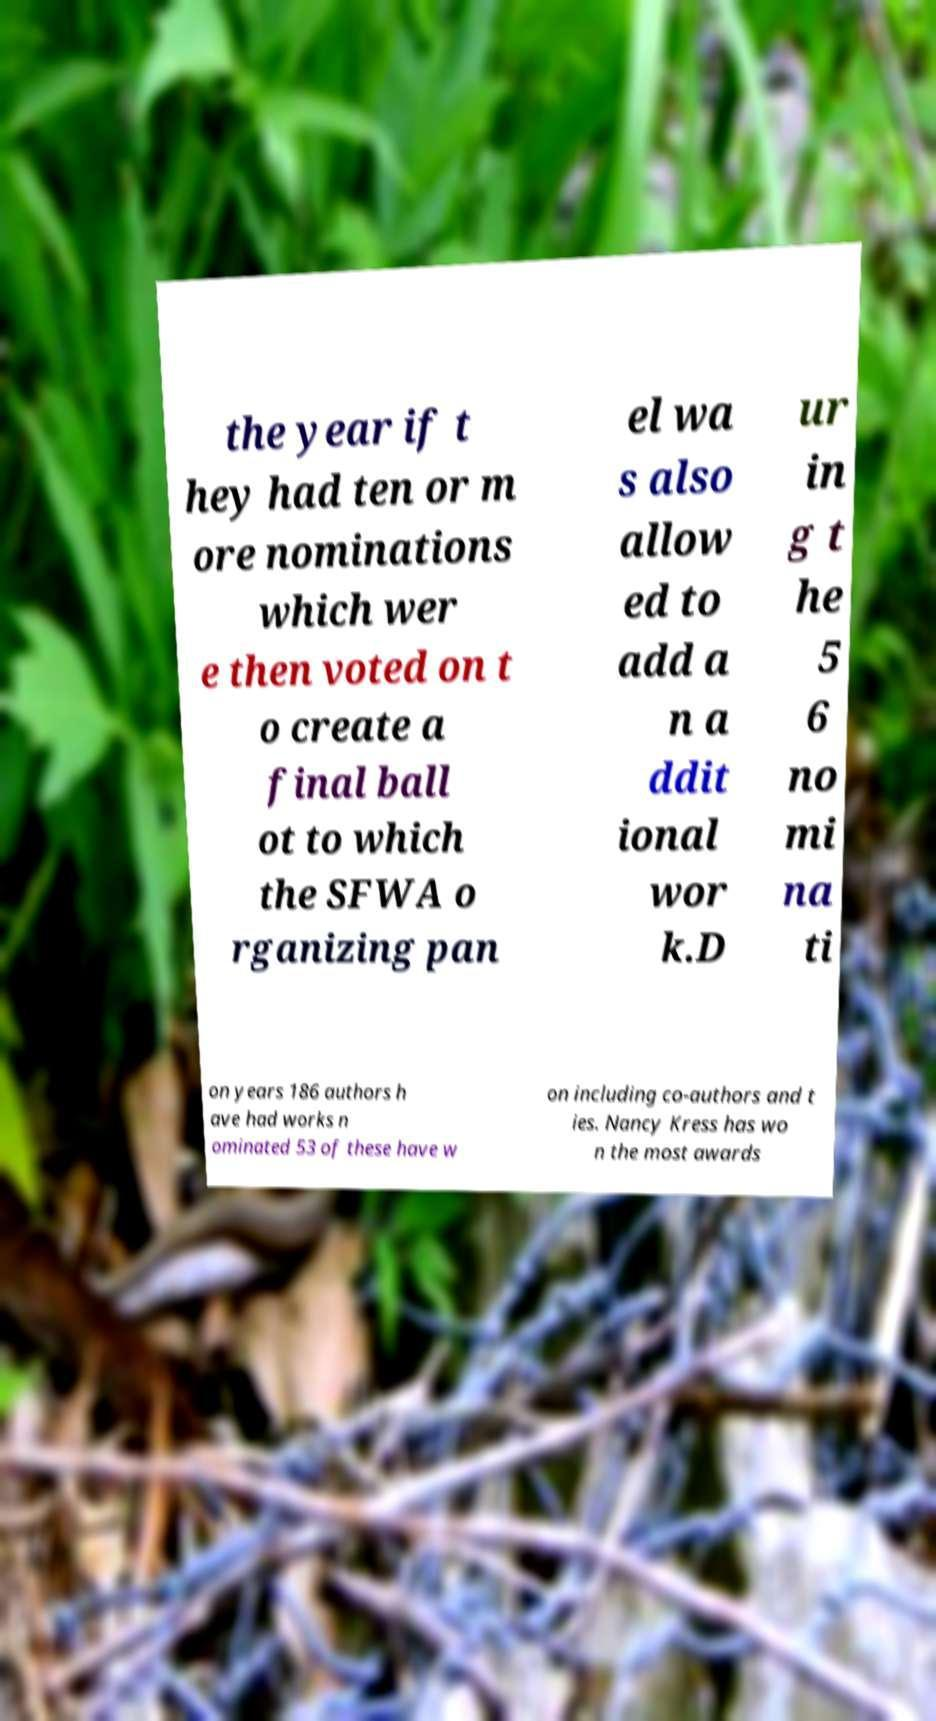For documentation purposes, I need the text within this image transcribed. Could you provide that? the year if t hey had ten or m ore nominations which wer e then voted on t o create a final ball ot to which the SFWA o rganizing pan el wa s also allow ed to add a n a ddit ional wor k.D ur in g t he 5 6 no mi na ti on years 186 authors h ave had works n ominated 53 of these have w on including co-authors and t ies. Nancy Kress has wo n the most awards 